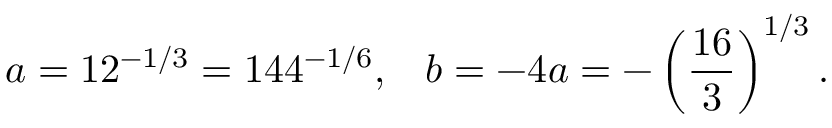<formula> <loc_0><loc_0><loc_500><loc_500>a = 1 2 ^ { - 1 / 3 } = 1 4 4 ^ { - 1 / 6 } , \, b = - 4 a = - \left ( \frac { 1 6 } { 3 } \right ) ^ { 1 / 3 } .</formula> 